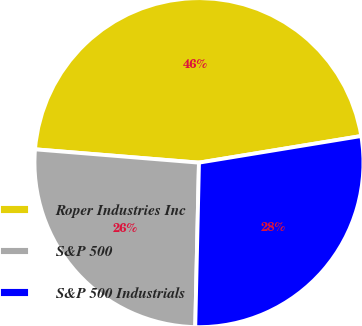<chart> <loc_0><loc_0><loc_500><loc_500><pie_chart><fcel>Roper Industries Inc<fcel>S&P 500<fcel>S&P 500 Industrials<nl><fcel>46.12%<fcel>25.93%<fcel>27.95%<nl></chart> 